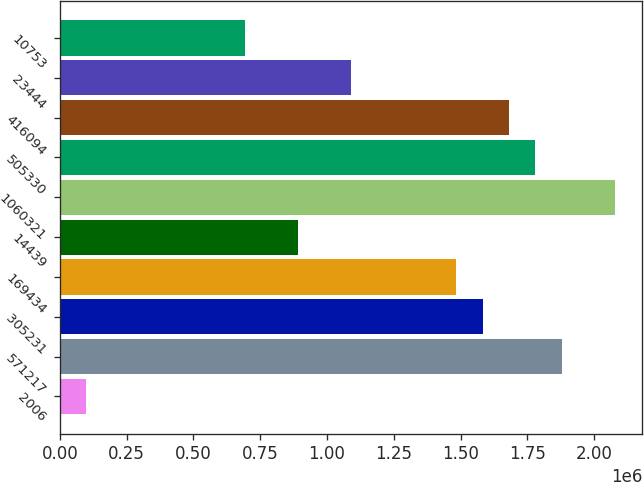Convert chart. <chart><loc_0><loc_0><loc_500><loc_500><bar_chart><fcel>2006<fcel>571217<fcel>305231<fcel>169434<fcel>14439<fcel>1060321<fcel>505330<fcel>416094<fcel>23444<fcel>10753<nl><fcel>98900.4<fcel>1.87911e+06<fcel>1.58241e+06<fcel>1.48351e+06<fcel>890104<fcel>2.07691e+06<fcel>1.78021e+06<fcel>1.68131e+06<fcel>1.0879e+06<fcel>692303<nl></chart> 